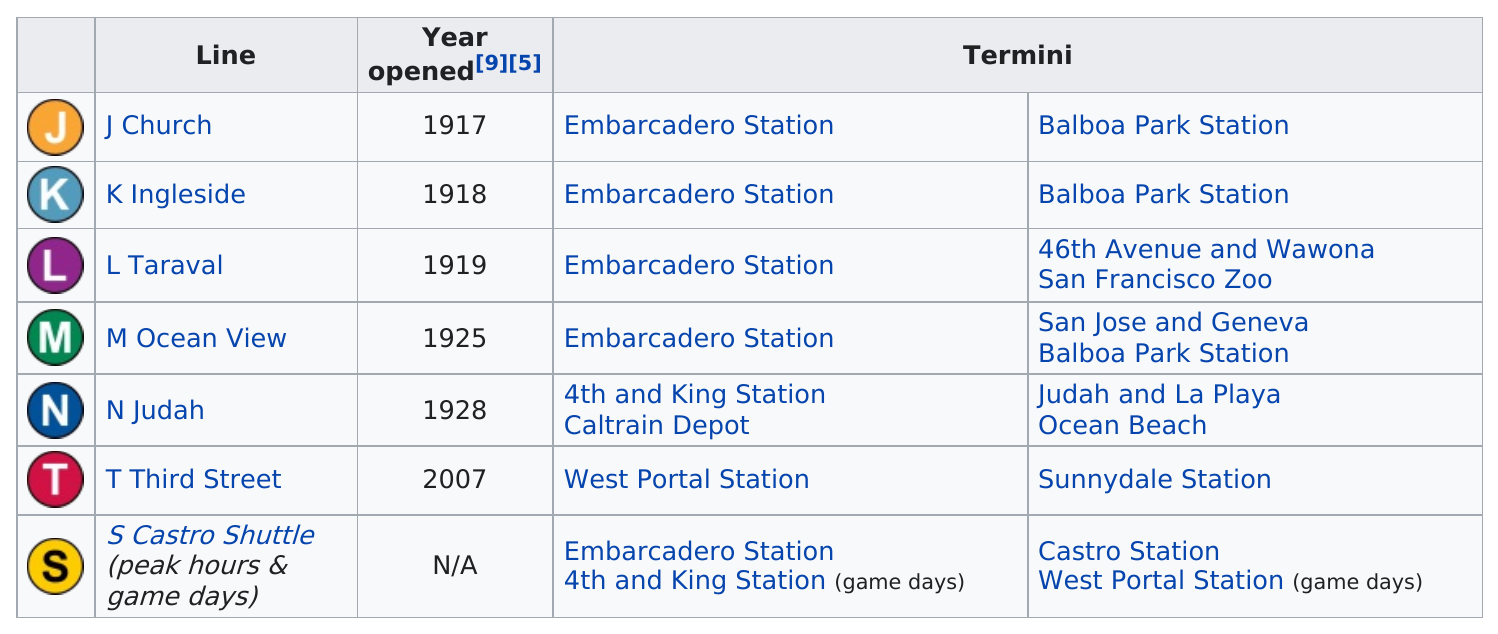Give some essential details in this illustration. On game days, I prefer to use the S Castro Shuttle. 